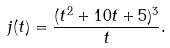Convert formula to latex. <formula><loc_0><loc_0><loc_500><loc_500>j ( t ) = \frac { ( t ^ { 2 } + 1 0 t + 5 ) ^ { 3 } } { t } .</formula> 